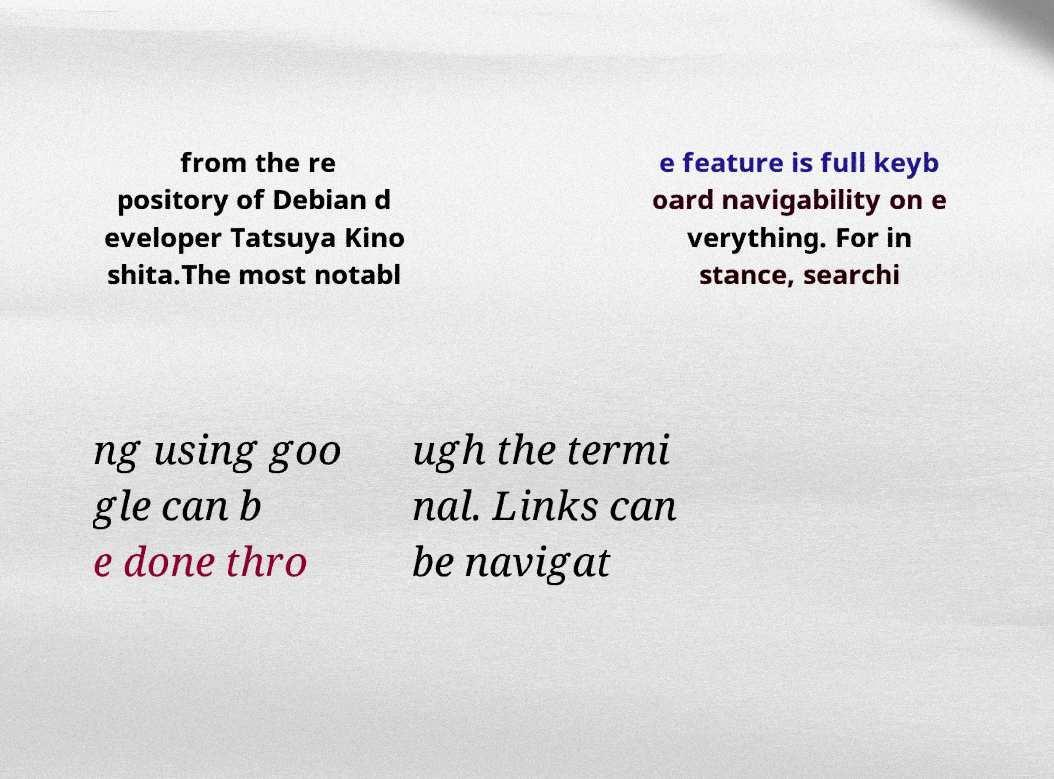Please identify and transcribe the text found in this image. from the re pository of Debian d eveloper Tatsuya Kino shita.The most notabl e feature is full keyb oard navigability on e verything. For in stance, searchi ng using goo gle can b e done thro ugh the termi nal. Links can be navigat 